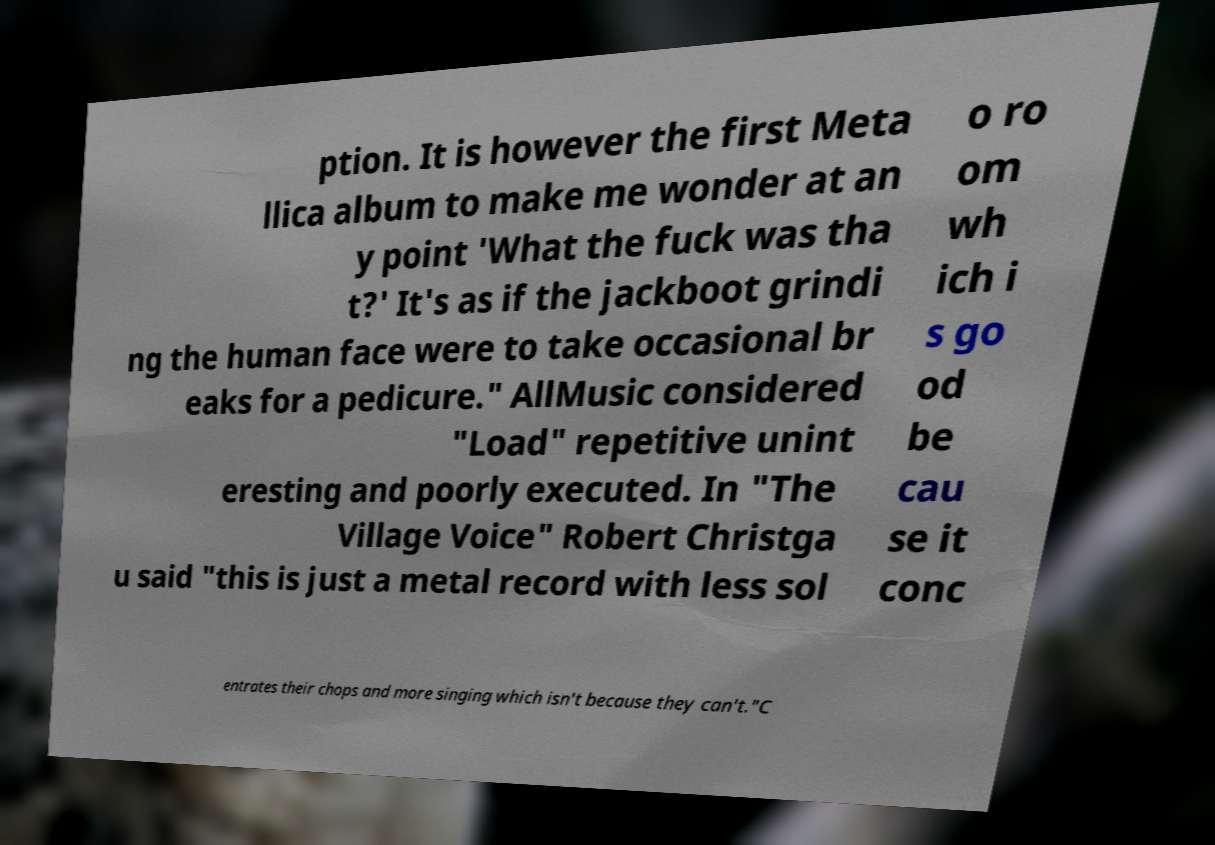What messages or text are displayed in this image? I need them in a readable, typed format. ption. It is however the first Meta llica album to make me wonder at an y point 'What the fuck was tha t?' It's as if the jackboot grindi ng the human face were to take occasional br eaks for a pedicure." AllMusic considered "Load" repetitive unint eresting and poorly executed. In "The Village Voice" Robert Christga u said "this is just a metal record with less sol o ro om wh ich i s go od be cau se it conc entrates their chops and more singing which isn't because they can't."C 